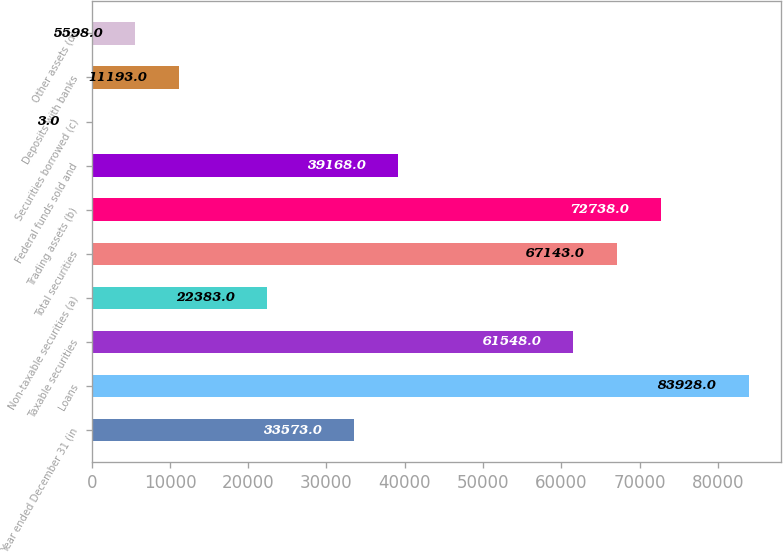<chart> <loc_0><loc_0><loc_500><loc_500><bar_chart><fcel>Year ended December 31 (in<fcel>Loans<fcel>Taxable securities<fcel>Non-taxable securities (a)<fcel>Total securities<fcel>Trading assets (b)<fcel>Federal funds sold and<fcel>Securities borrowed (c)<fcel>Deposits with banks<fcel>Other assets (d)<nl><fcel>33573<fcel>83928<fcel>61548<fcel>22383<fcel>67143<fcel>72738<fcel>39168<fcel>3<fcel>11193<fcel>5598<nl></chart> 